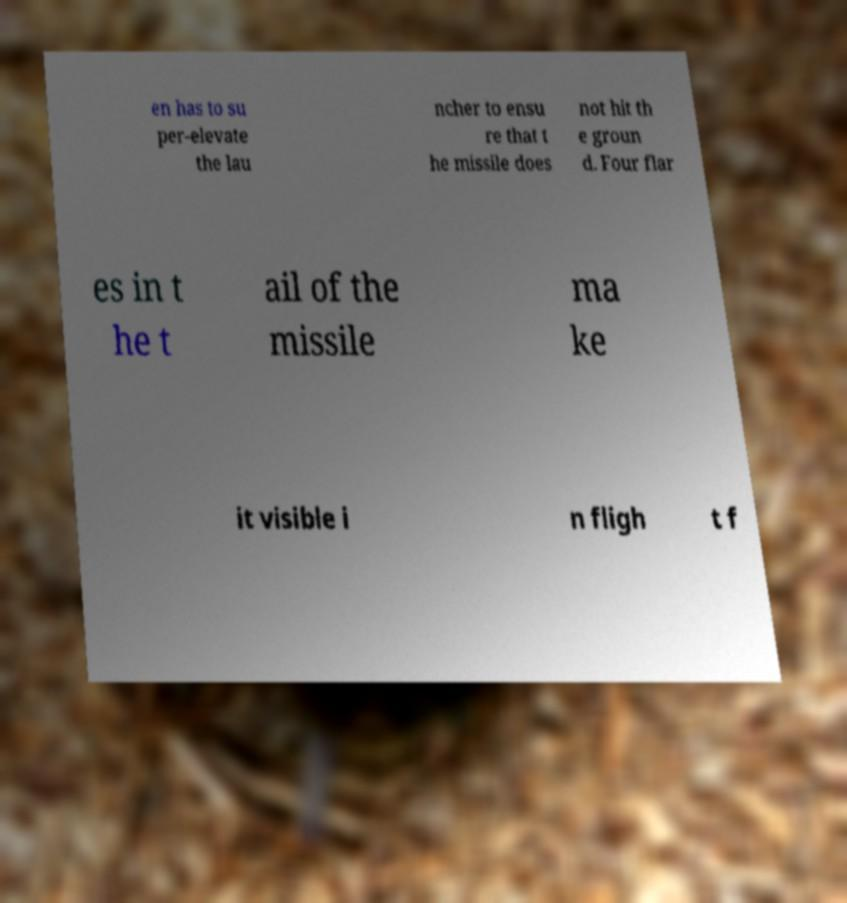What messages or text are displayed in this image? I need them in a readable, typed format. en has to su per-elevate the lau ncher to ensu re that t he missile does not hit th e groun d. Four flar es in t he t ail of the missile ma ke it visible i n fligh t f 